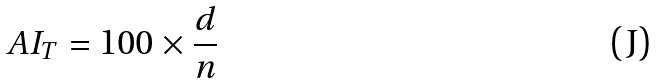<formula> <loc_0><loc_0><loc_500><loc_500>A I _ { T } = 1 0 0 \times \frac { d } { n }</formula> 